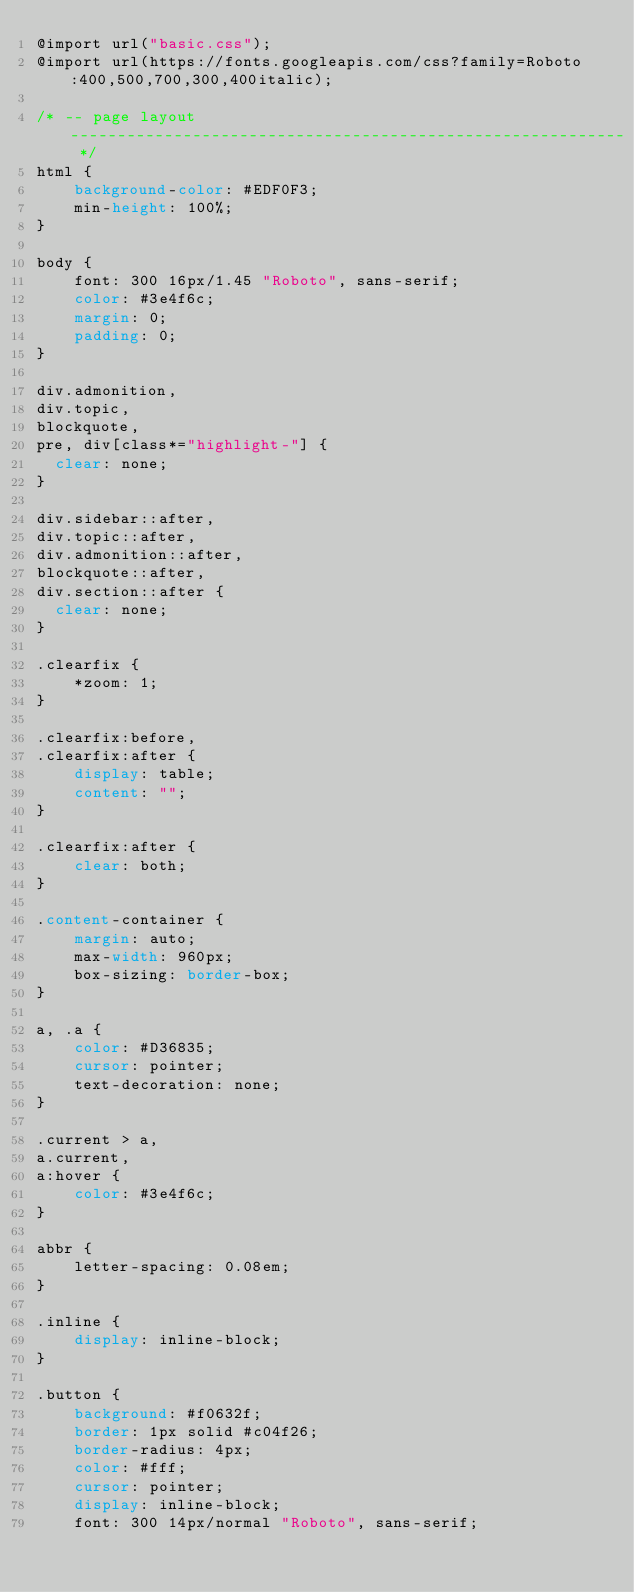Convert code to text. <code><loc_0><loc_0><loc_500><loc_500><_CSS_>@import url("basic.css");
@import url(https://fonts.googleapis.com/css?family=Roboto:400,500,700,300,400italic);

/* -- page layout ----------------------------------------------------------- */
html {
    background-color: #EDF0F3;
    min-height: 100%;
}

body {
    font: 300 16px/1.45 "Roboto", sans-serif;
    color: #3e4f6c;
    margin: 0;
    padding: 0;
}

div.admonition,
div.topic,
blockquote,
pre, div[class*="highlight-"] {
  clear: none;
}

div.sidebar::after,
div.topic::after,
div.admonition::after,
blockquote::after,
div.section::after {
  clear: none;
}

.clearfix {
    *zoom: 1;
}

.clearfix:before,
.clearfix:after {
    display: table;
    content: "";
}

.clearfix:after {
    clear: both;
}

.content-container {
    margin: auto;
    max-width: 960px;
    box-sizing: border-box;
}

a, .a {
    color: #D36835;
    cursor: pointer;
    text-decoration: none;
}

.current > a,
a.current,
a:hover {
    color: #3e4f6c;
}

abbr {
    letter-spacing: 0.08em;
}

.inline {
    display: inline-block;
}

.button {
    background: #f0632f;
    border: 1px solid #c04f26;
    border-radius: 4px;
    color: #fff;
    cursor: pointer;
    display: inline-block;
    font: 300 14px/normal "Roboto", sans-serif;</code> 